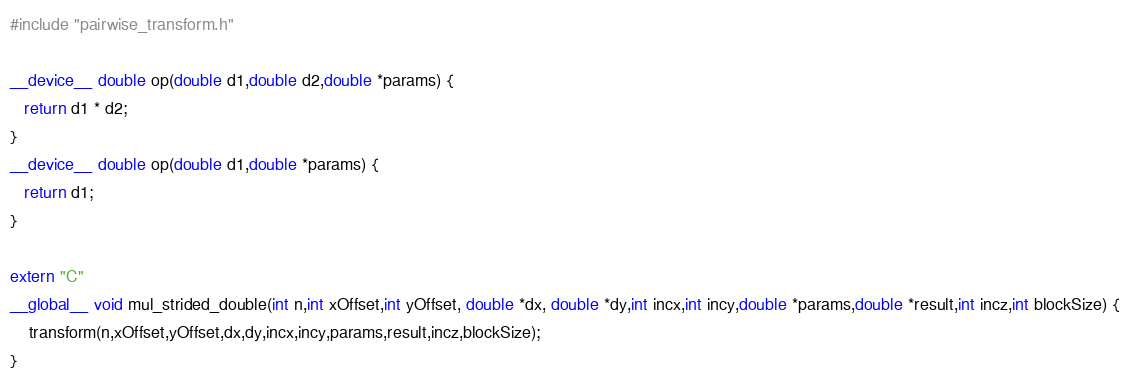<code> <loc_0><loc_0><loc_500><loc_500><_Cuda_>#include "pairwise_transform.h"

__device__ double op(double d1,double d2,double *params) {
   return d1 * d2;
}
__device__ double op(double d1,double *params) {
   return d1;
}

extern "C"
__global__ void mul_strided_double(int n,int xOffset,int yOffset, double *dx, double *dy,int incx,int incy,double *params,double *result,int incz,int blockSize) {
    transform(n,xOffset,yOffset,dx,dy,incx,incy,params,result,incz,blockSize);
}</code> 